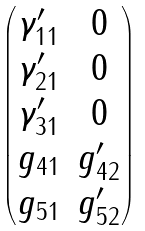Convert formula to latex. <formula><loc_0><loc_0><loc_500><loc_500>\begin{pmatrix} \gamma _ { 1 1 } ^ { \prime } & 0 \\ \gamma _ { 2 1 } ^ { \prime } & 0 \\ \gamma _ { 3 1 } ^ { \prime } & 0 \\ g _ { 4 1 } & g _ { 4 2 } ^ { \prime } \\ g _ { 5 1 } & g _ { 5 2 } ^ { \prime } \end{pmatrix}</formula> 